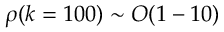Convert formula to latex. <formula><loc_0><loc_0><loc_500><loc_500>\rho ( k = 1 0 0 ) \sim O ( 1 - 1 0 )</formula> 